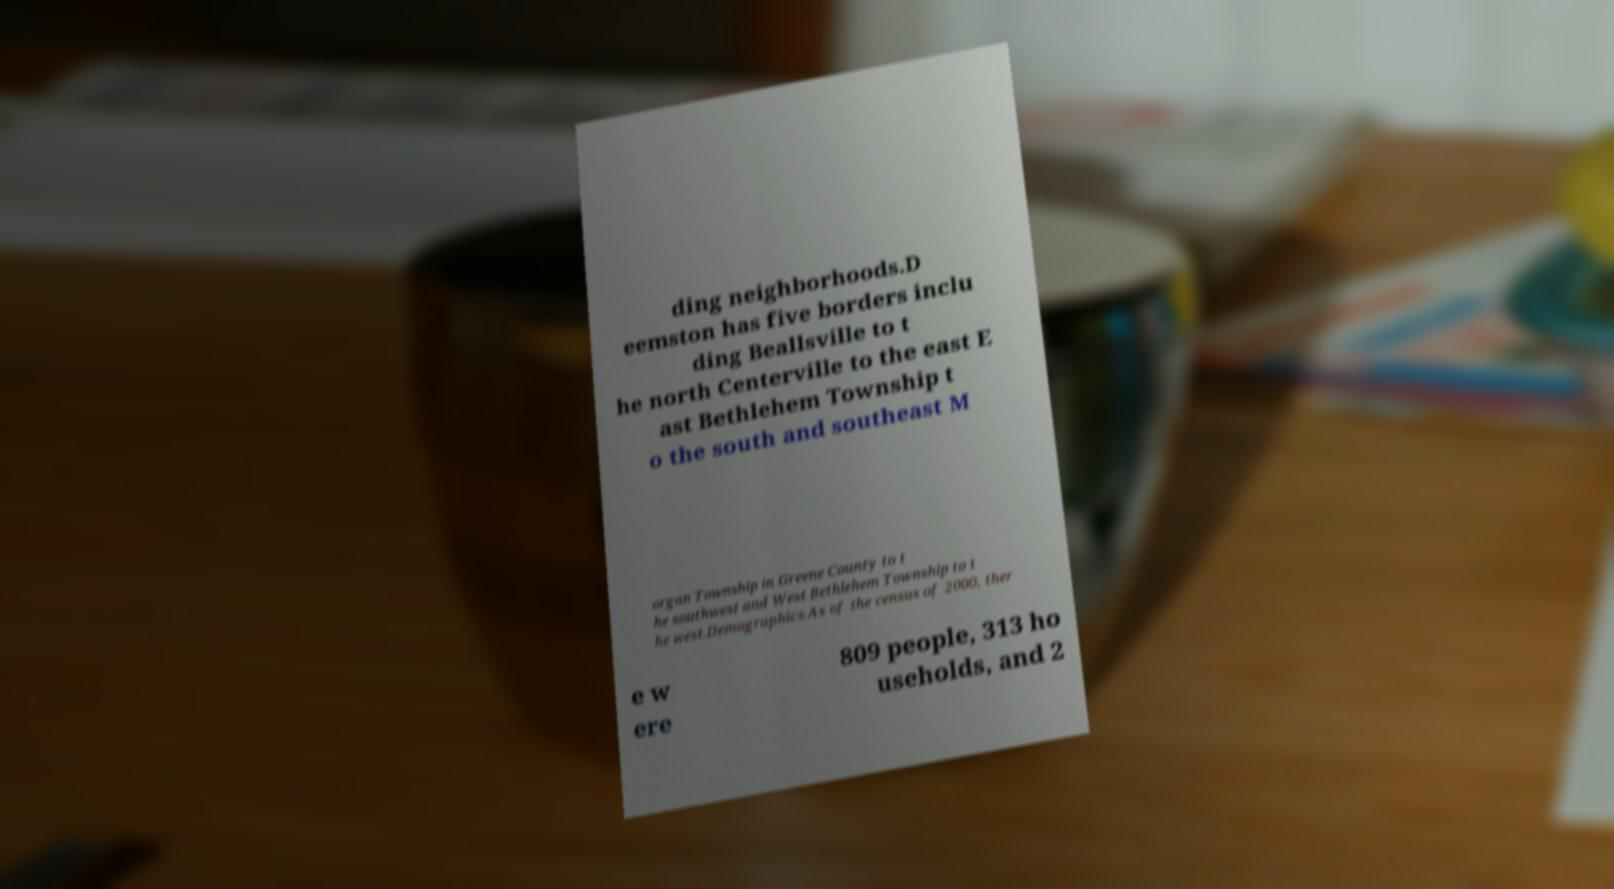For documentation purposes, I need the text within this image transcribed. Could you provide that? ding neighborhoods.D eemston has five borders inclu ding Beallsville to t he north Centerville to the east E ast Bethlehem Township t o the south and southeast M organ Township in Greene County to t he southwest and West Bethlehem Township to t he west.Demographics.As of the census of 2000, ther e w ere 809 people, 313 ho useholds, and 2 